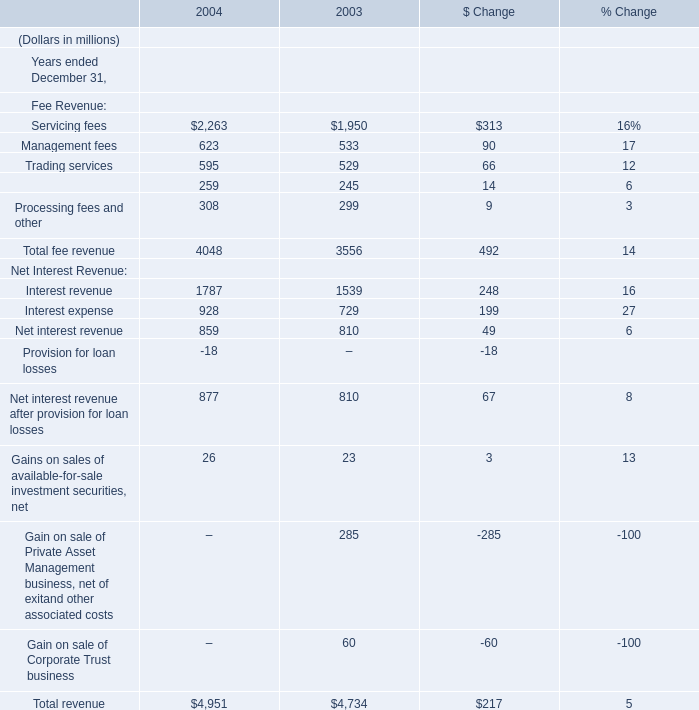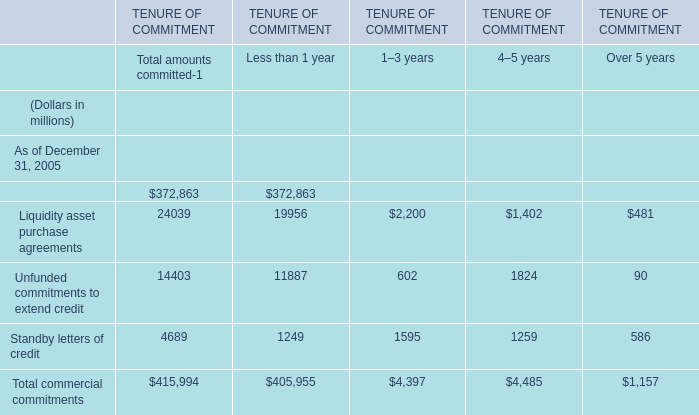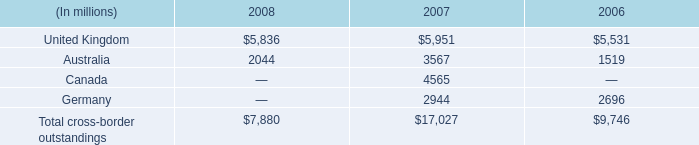what percent increase did the united kingdom cross border outstandings experience between 2006 and 2008? 
Computations: ((5836 - 5531) / 5531)
Answer: 0.05514. 